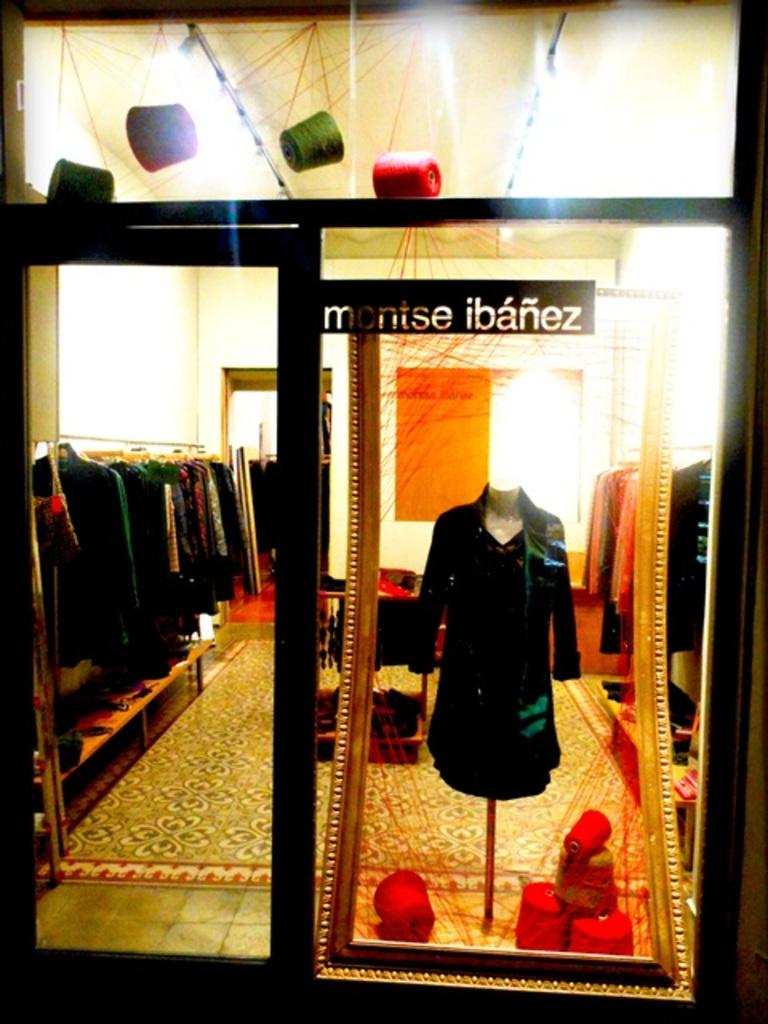What type of clothing can be seen in the image? There are dress costumes in the image. Where are the dress costumes located? The dress costumes are inside a shop. What can be seen on the roof in the image? There are lights on the roof in the image. Can you see any lamps in the garden in the image? There is no garden or lamp present in the image. 